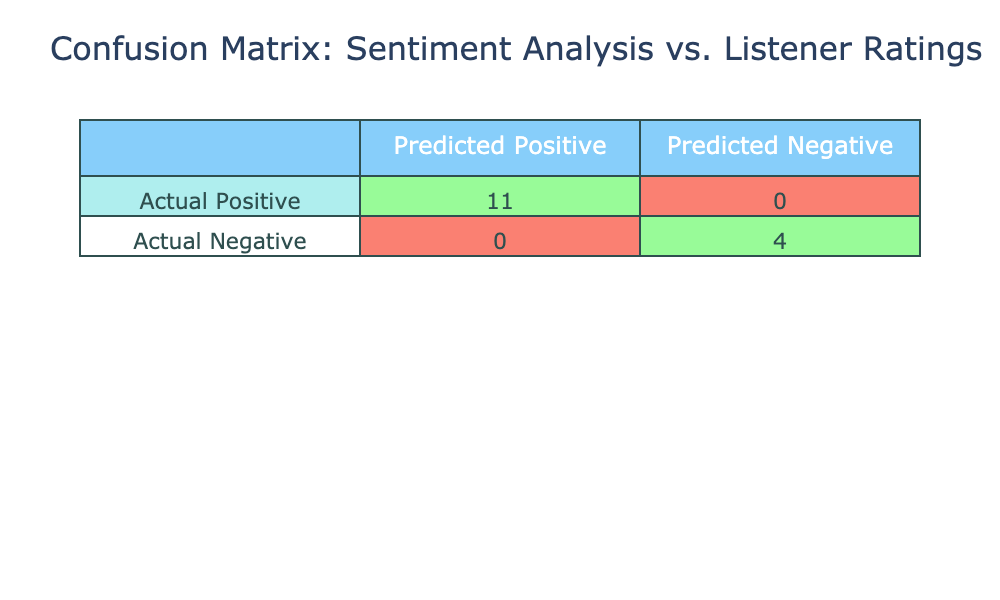What is the number of true positives in the confusion matrix? True positives are counted as the songs that have a listener rating of 3 or higher and have been predicted as positive. From the table, counting those, we have: "Gentle On My Mind," "Wichita Lineman," "Southern Nights," "Rhinestone Cowboy," "By The Time I Get To Phoenix," "Storms Never Last," "The Last Time I Saw Her," and "Where's The Playground Susie," totaling 8 songs.
Answer: 8 What is the number of false negatives in the confusion matrix? False negatives are the songs that have a listener rating of 3 or higher but are predicted to be negative. In the provided data, there are no songs matching this criteria, so the count is 0.
Answer: 0 How many songs were predicted to have a positive sentiment but actually had a listener rating lower than 3? Songs predicted as positive but rated lower than 3 are counted as false positives. From the data, "It's Only Make Believe," "Dreams Of The Everyday Housewife," "Country Boy," and "It's a Sin" fall into this category, giving a total of 4 false positives.
Answer: 4 Is it true that all the songs with a sentiment analysis score above 0.75 have been predicted as positive? To check this, I look at all songs with scores above 0.75: "Gentle On My Mind," "Wichita Lineman," "Southern Nights," "By The Time I Get To Phoenix," and "Storms Never Last." All of these songs are predicted as positive, which confirms the statement is true.
Answer: True What is the percentage of actual positives (listener ratings of 3 or higher) out of the total songs analyzed? To find this percentage, I first count the total number of songs, which is 14. Then, I count the actual positives: "Gentle On My Mind," "Wichita Lineman," "Southern Nights," "Rhinestone Cowboy," "By The Time I Get To Phoenix," "Galveston," "Storms Never Last," "The Last Time I Saw Her," and "Where's The Playground Susie," totaling 9 songs rated 3 or higher. The percentage is calculated as (9/14)*100, which equals approximately 64.29%.
Answer: 64.29% What is the difference in the number of true negatives and false positives? True negatives are counted as songs with listener ratings below 3 that were correctly predicted as negative. From the table, both "It's Only Make Believe" and "Country Boy" were rated below 3 and predicted negative, so there are 3 true negatives total. False positives were calculated as 4, resulting in a difference of 3 - 4 = -1.
Answer: -1 